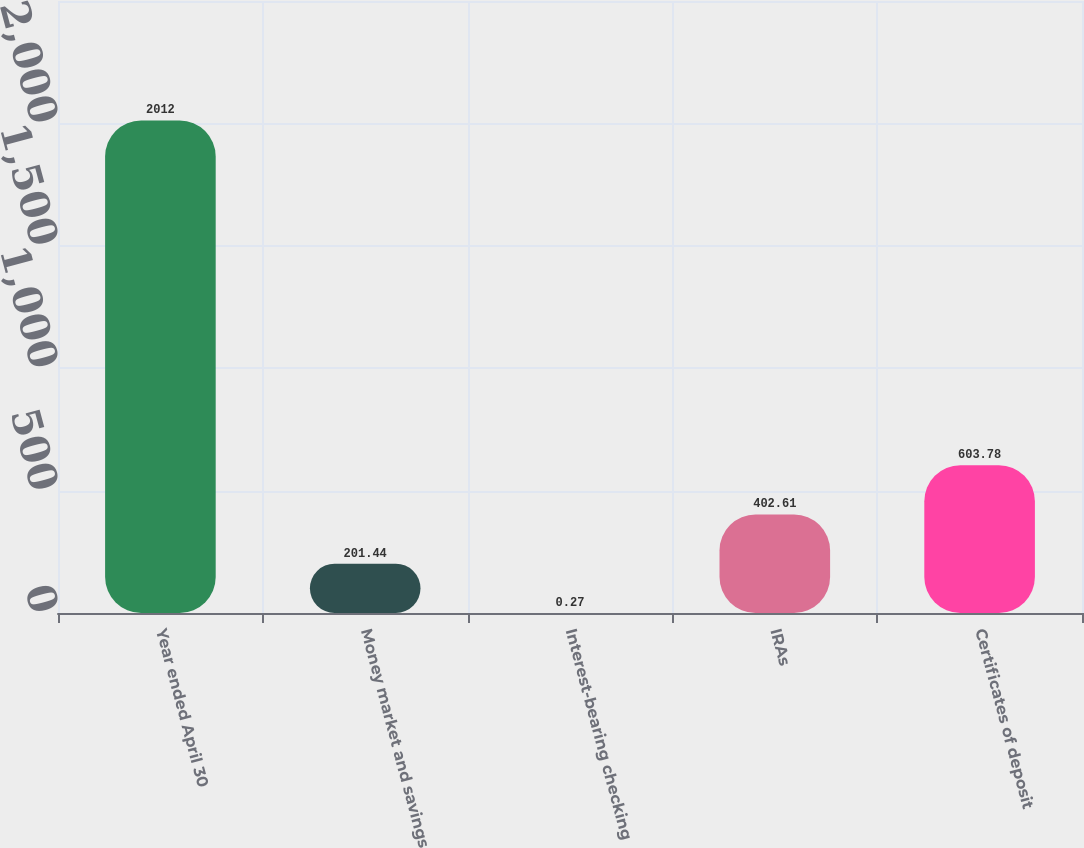Convert chart to OTSL. <chart><loc_0><loc_0><loc_500><loc_500><bar_chart><fcel>Year ended April 30<fcel>Money market and savings<fcel>Interest-bearing checking<fcel>IRAs<fcel>Certificates of deposit<nl><fcel>2012<fcel>201.44<fcel>0.27<fcel>402.61<fcel>603.78<nl></chart> 